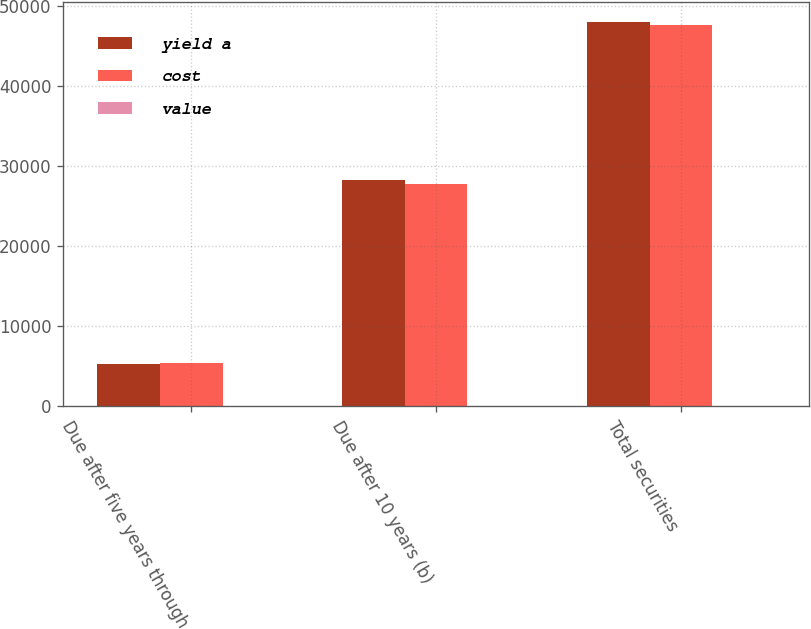Convert chart. <chart><loc_0><loc_0><loc_500><loc_500><stacked_bar_chart><ecel><fcel>Due after five years through<fcel>Due after 10 years (b)<fcel>Total securities<nl><fcel>yield a<fcel>5346<fcel>28184<fcel>47993<nl><fcel>cost<fcel>5366<fcel>27722<fcel>47523<nl><fcel>value<fcel>4.7<fcel>4.69<fcel>4.27<nl></chart> 